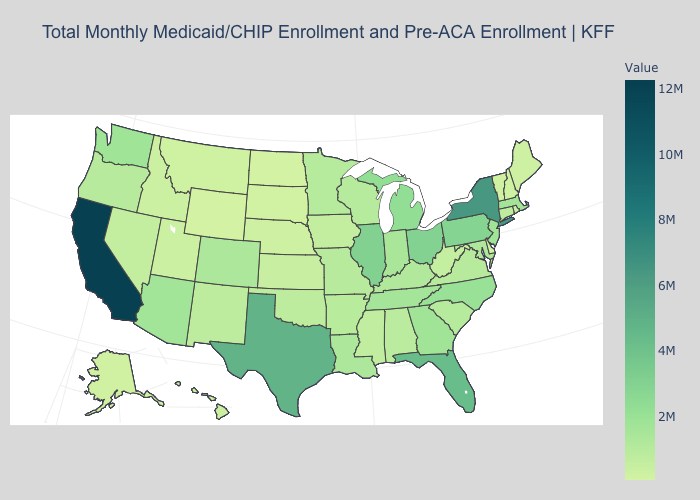Is the legend a continuous bar?
Be succinct. Yes. Among the states that border New Mexico , does Oklahoma have the highest value?
Short answer required. No. Does New Jersey have a higher value than Alaska?
Answer briefly. Yes. 